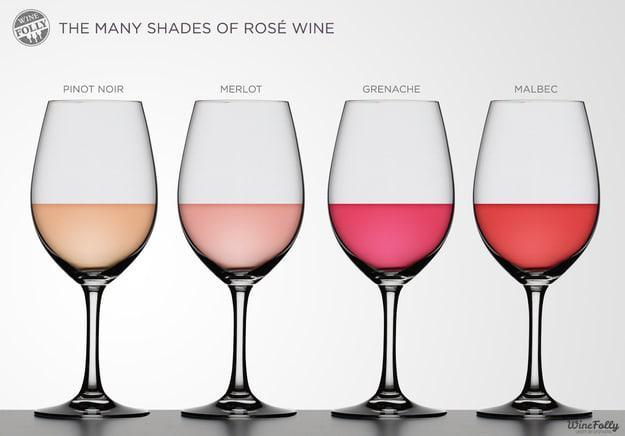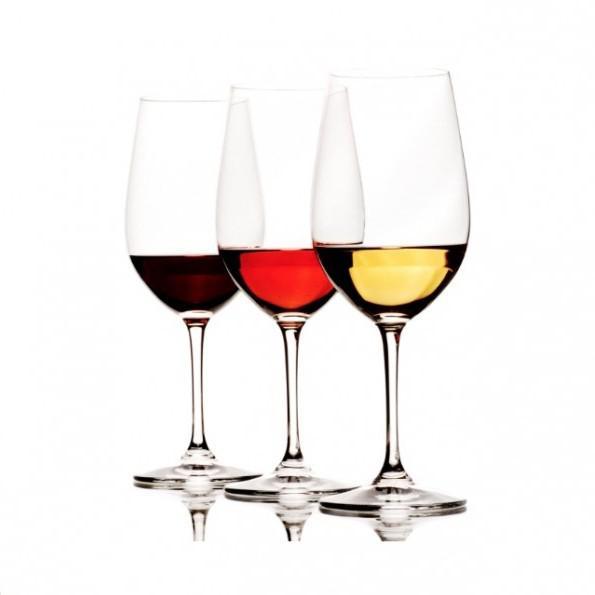The first image is the image on the left, the second image is the image on the right. Analyze the images presented: Is the assertion "Each image shows exactly three wine glasses, which contain different colors of wine." valid? Answer yes or no. No. The first image is the image on the left, the second image is the image on the right. For the images displayed, is the sentence "The wine glass furthest to the right in the right image contains dark red liquid." factually correct? Answer yes or no. No. 